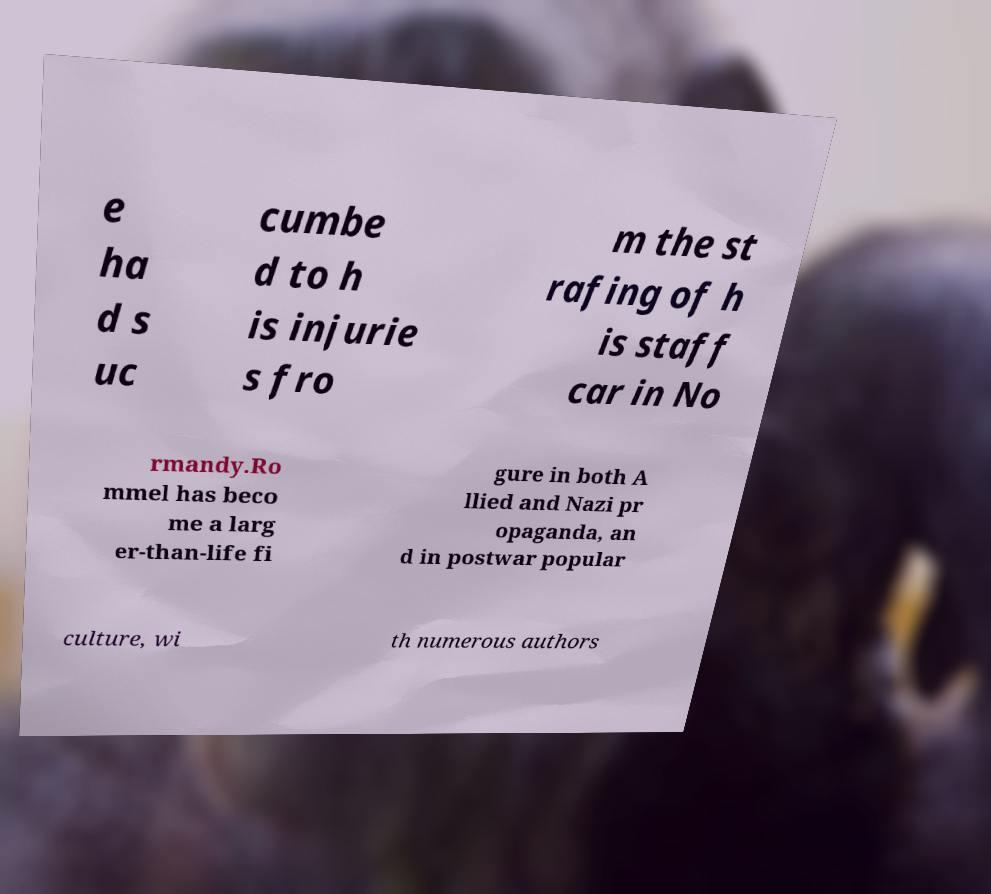Could you extract and type out the text from this image? e ha d s uc cumbe d to h is injurie s fro m the st rafing of h is staff car in No rmandy.Ro mmel has beco me a larg er-than-life fi gure in both A llied and Nazi pr opaganda, an d in postwar popular culture, wi th numerous authors 